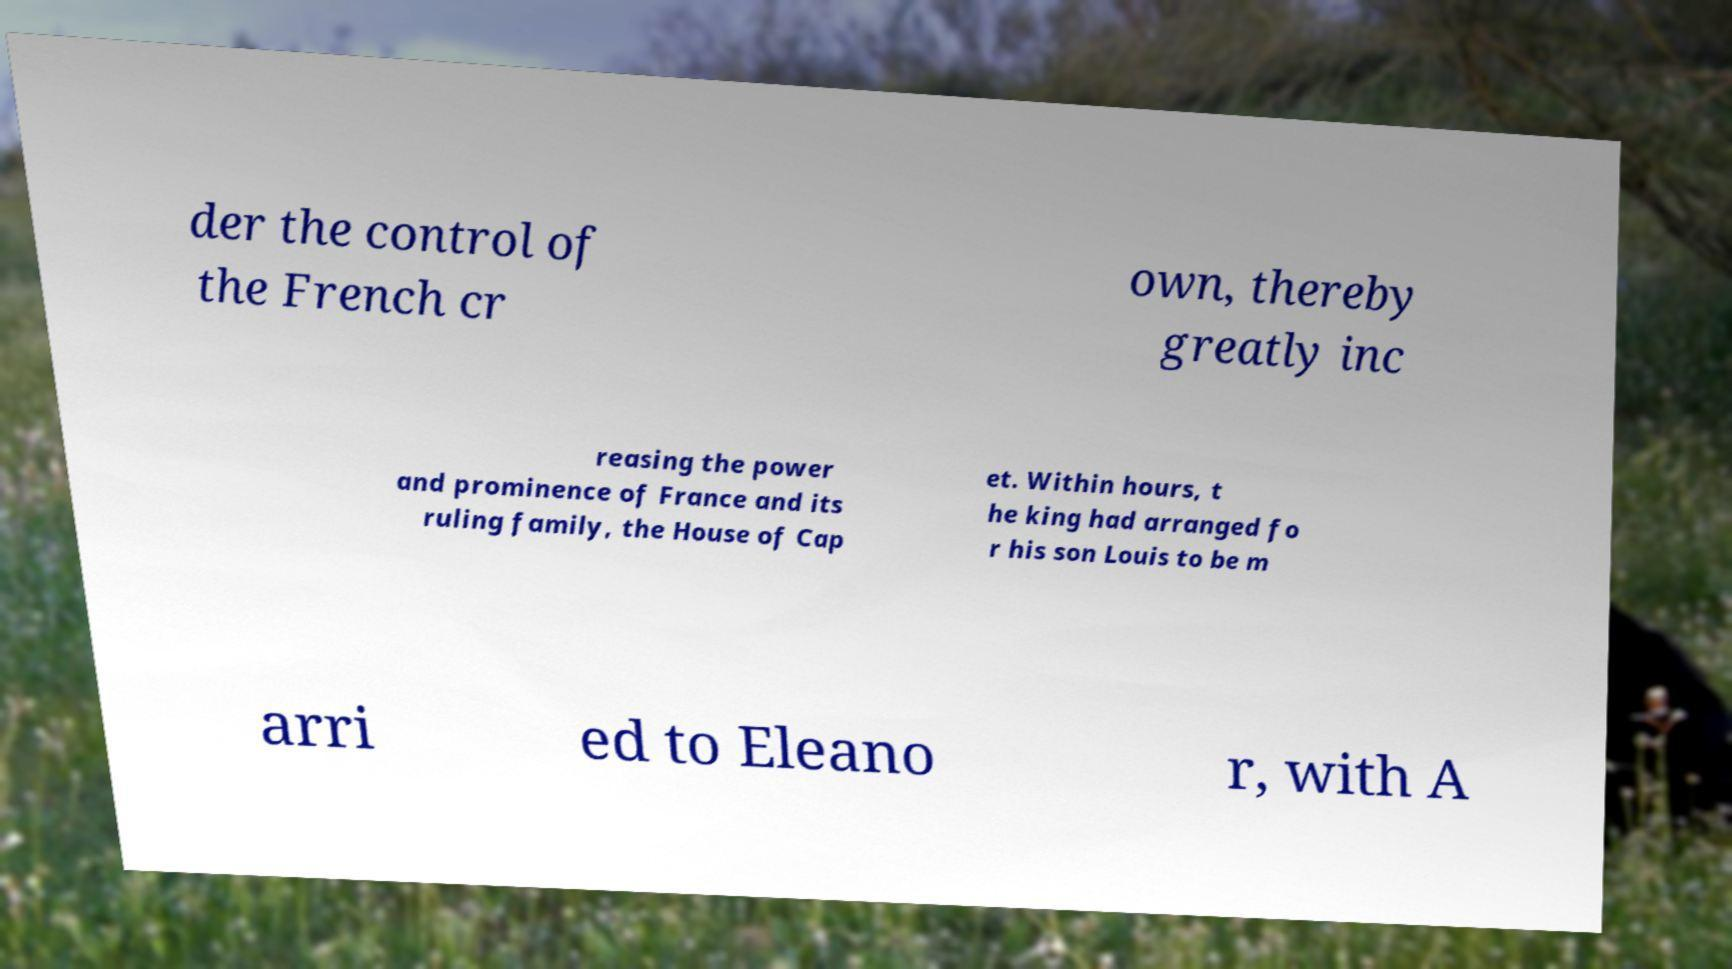Could you assist in decoding the text presented in this image and type it out clearly? der the control of the French cr own, thereby greatly inc reasing the power and prominence of France and its ruling family, the House of Cap et. Within hours, t he king had arranged fo r his son Louis to be m arri ed to Eleano r, with A 